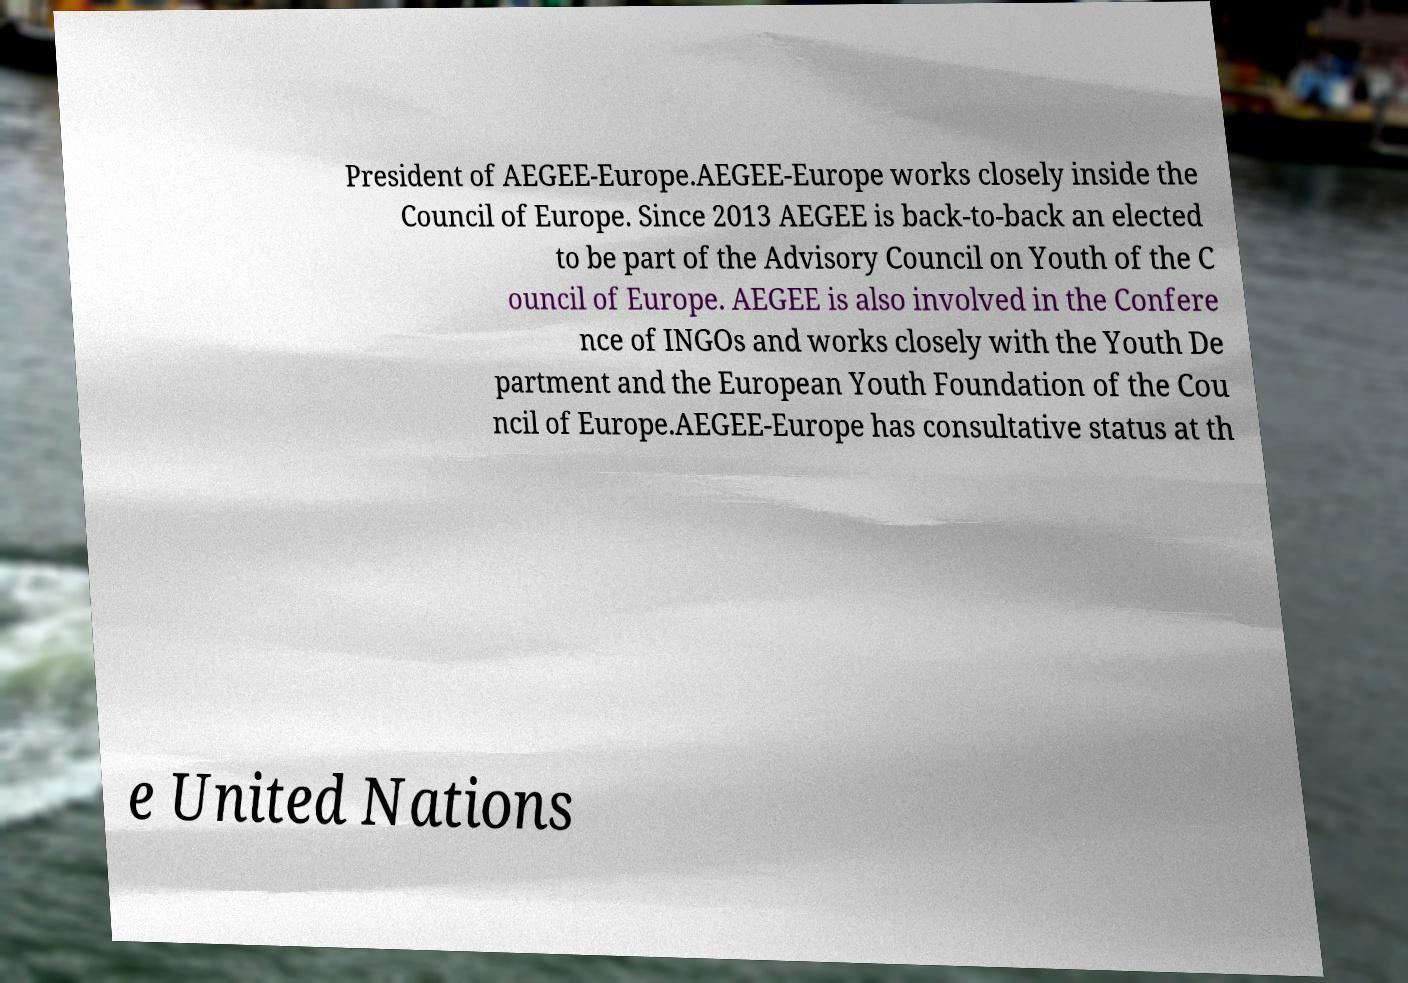Could you extract and type out the text from this image? President of AEGEE-Europe.AEGEE-Europe works closely inside the Council of Europe. Since 2013 AEGEE is back-to-back an elected to be part of the Advisory Council on Youth of the C ouncil of Europe. AEGEE is also involved in the Confere nce of INGOs and works closely with the Youth De partment and the European Youth Foundation of the Cou ncil of Europe.AEGEE-Europe has consultative status at th e United Nations 